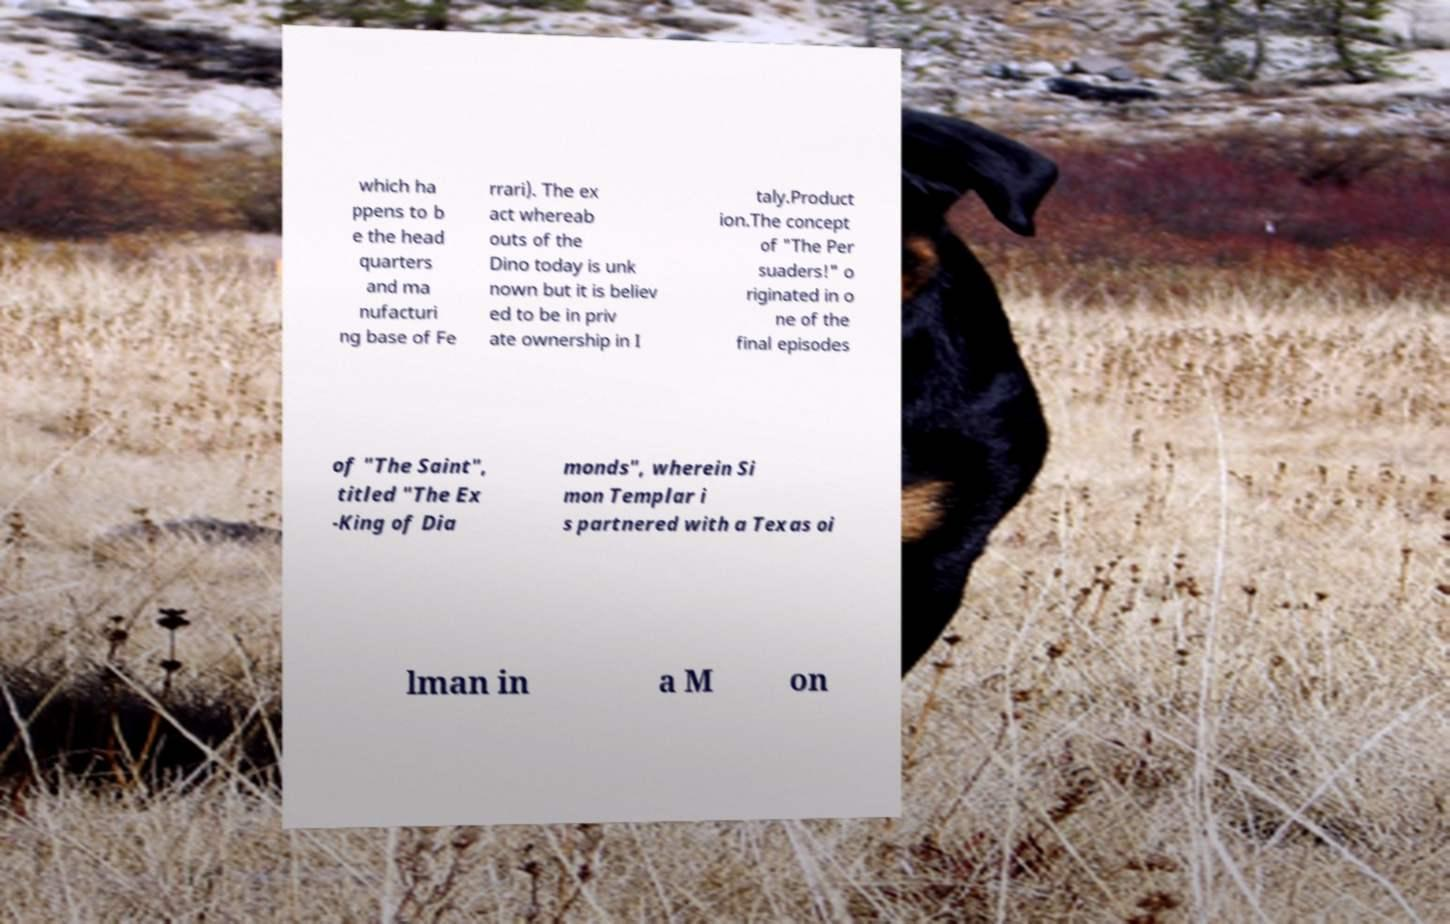What messages or text are displayed in this image? I need them in a readable, typed format. which ha ppens to b e the head quarters and ma nufacturi ng base of Fe rrari). The ex act whereab outs of the Dino today is unk nown but it is believ ed to be in priv ate ownership in I taly.Product ion.The concept of "The Per suaders!" o riginated in o ne of the final episodes of "The Saint", titled "The Ex -King of Dia monds", wherein Si mon Templar i s partnered with a Texas oi lman in a M on 